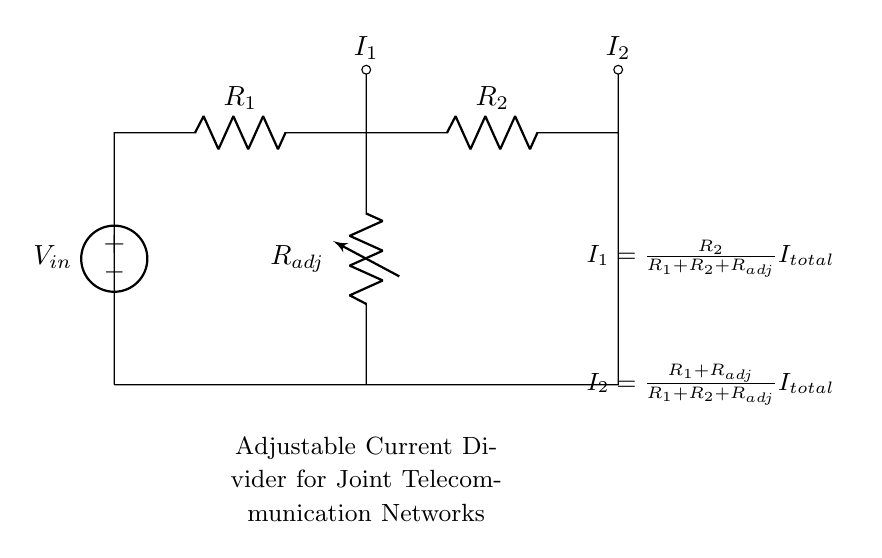What is the input voltage of the circuit? The input voltage is indicated by the label \( V_{in} \) at the voltage source on the circuit diagram.
Answer: V_in What does \( I_1 \) represent? \( I_1 \) represents the current flowing through resistor \( R_2 \) as indicated by its label in the diagram and the governing equations provided.
Answer: Current through R_2 How many resistors are present in this circuit? The circuit contains three resistors: \( R_1 \), \( R_2 \), and \( R_{adj} \) as shown in the diagram.
Answer: Three What happens to \( I_1 \) if \( R_{adj} \) decreases? If \( R_{adj} \) decreases, according to the formula \( I_1 = \frac{R_2}{R_1 + R_2 + R_{adj}} I_{total} \), \( I_1 \) will increase due to the reduction in the denominator.
Answer: \( I_1 \) increases What is the function of \( R_{adj} \)? \( R_{adj} \) is a variable resistor that allows for the adjustment of the current division between \( I_1 \) and \( I_2 \) in the circuit, thereby regulating power distribution in the telecommunication network.
Answer: Adjustable current control How does \( R_1 \) affect \( I_2 \)? The current \( I_2 \) is given by \( I_2 = \frac{R_1 + R_{adj}}{R_1 + R_2 + R_{adj}} I_{total} \), meaning that as \( R_1 \) increases, \( I_2 \) also tends to increase since it is in the numerator of the formula.
Answer: \( I_2 \) increases 